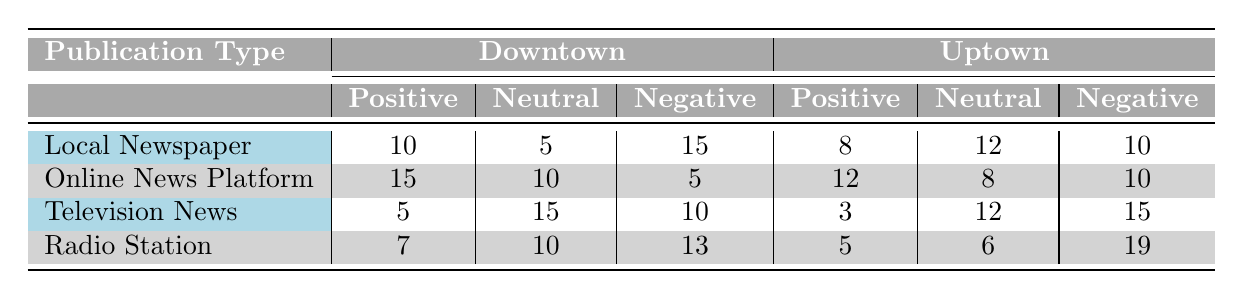What is the positive sentiment score for Online News Platforms in Downtown? According to the table, the positive sentiment score for Online News Platforms in Downtown is listed as 15.
Answer: 15 Which publication type received the most negative sentiment in Uptown? By looking at the Uptown column, the negative sentiment scores are: Local Newspaper (10), Online News Platform (10), Television News (15), and Radio Station (19). The highest value is 19 associated with Radio Station.
Answer: Radio Station What is the total positive sentiment for Local Newspapers across both regions? The positive sentiment for Local Newspapers is 10 in Downtown and 8 in Uptown. Adding these gives a total of 10 + 8 = 18.
Answer: 18 Is there a publication type that has a lower neutral sentiment in Uptown compared to Downtown? In Uptown, the neutral sentiments are 12 for Local Newspaper, 8 for Online News Platform, 12 for Television News, and 6 for Radio Station. In Downtown, the neutral sentiments are 5 for Local Newspaper, 10 for Online News Platform, 15 for Television News, and 10 for Radio Station. Radio Station has a neutral sentiment of 6 in Uptown compared to 10 in Downtown, indicating it is lower.
Answer: Yes What is the difference in neutral sentiment between Radio Station in Downtown and Uptown? In Downtown, Radio Station has a neutral sentiment of 10, while in Uptown, it is 6. The difference is calculated as 10 - 6 = 4.
Answer: 4 Which publication type has the highest overall negative sentiment across both regions? The total negative sentiment scores are as follows: Local Newspaper (15 + 10 = 25), Online News Platform (5 + 10 = 15), Television News (10 + 15 = 25), and Radio Station (13 + 19 = 32). Radio Station with a total of 32 has the highest negative sentiment.
Answer: Radio Station What publication type had the least positive sentiment in both regions combined? Adding the positive sentiments: Local Newspaper (10 + 8 = 18), Online News Platform (15 + 12 = 27), Television News (5 + 3 = 8), Radio Station (7 + 5 = 12). Television News has the least with a total of 8.
Answer: Television News How much greater was the positive sentiment for Online News Platforms in Downtown compared to Television News in Uptown? The positive sentiment for Online News Platforms in Downtown is 15, and for Television News in Uptown, it is 3. The difference is 15 - 3 = 12.
Answer: 12 